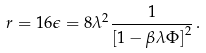<formula> <loc_0><loc_0><loc_500><loc_500>r = 1 6 \epsilon = { 8 \lambda ^ { 2 } } \frac { 1 } { \left [ 1 - \beta \lambda \Phi \right ] ^ { 2 } } \, .</formula> 